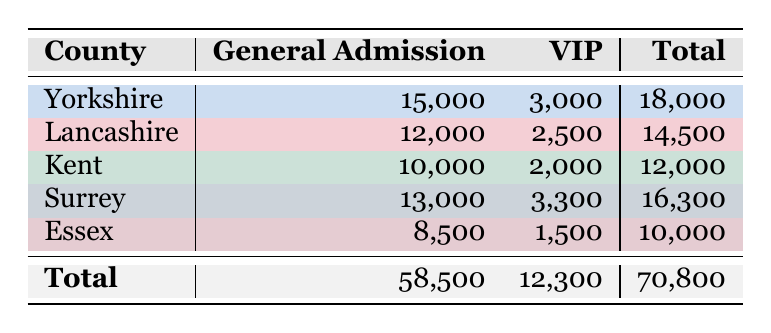What is the total attendance for Yorkshire cricket matches? In the table, the attendance for Yorkshire is listed as 15,000 for General Admission and 3,000 for VIP. To find the total, we add these two values: 15,000 + 3,000 = 18,000.
Answer: 18,000 Which county has the highest attendance for General Admission? By examining the General Admission figures in the table, we compare them: Yorkshire (15,000), Lancashire (12,000), Kent (10,000), Surrey (13,000), and Essex (8,500). Yorkshire has the highest number with 15,000 attendees.
Answer: Yorkshire Is the total VIP attendance for all counties greater than 10,000? We need to sum the VIP attendances from the table: Yorkshire (3,000), Lancashire (2,500), Kent (2,000), Surrey (3,300), and Essex (1,500). Calculating gives us: 3,000 + 2,500 + 2,000 + 3,300 + 1,500 = 12,300, which is indeed greater than 10,000.
Answer: Yes What is the difference between the total attendance of Surrey and Kent? From the table, Surrey's total attendance is 16,300 and Kent's total is 12,000. The difference can be calculated as: 16,300 - 12,000 = 4,300.
Answer: 4,300 Which county has the least number of attendees for VIP tickets, and what is the count? Looking at the VIP attendees in the table, we have the following numbers: Yorkshire (3,000), Lancashire (2,500), Kent (2,000), Surrey (3,300), and Essex (1,500). The lowest value is Essex with 1,500 attendees.
Answer: Essex, 1,500 What percentage of the total attendance is made up of General Admission tickets? The total attendance across all counties is 70,800. The total for General Admission is 58,500. To find the percentage, we calculate: (58,500 / 70,800) * 100 = approximately 82.7%.
Answer: 82.7% How many more attendees chose General Admission than VIP across all counties? First, we find the total number of General Admission attendees (58,500) and VIP attendees (12,300). We then calculate the difference: 58,500 - 12,300 = 46,200 more attendees chose General Admission.
Answer: 46,200 What is the average attendance for VIP tickets across all counties? We calculate the total VIP attendance (12,300) and divide it by the number of counties (5): 12,300 / 5 = 2,460. The average attendance for VIP tickets across all counties is 2,460.
Answer: 2,460 